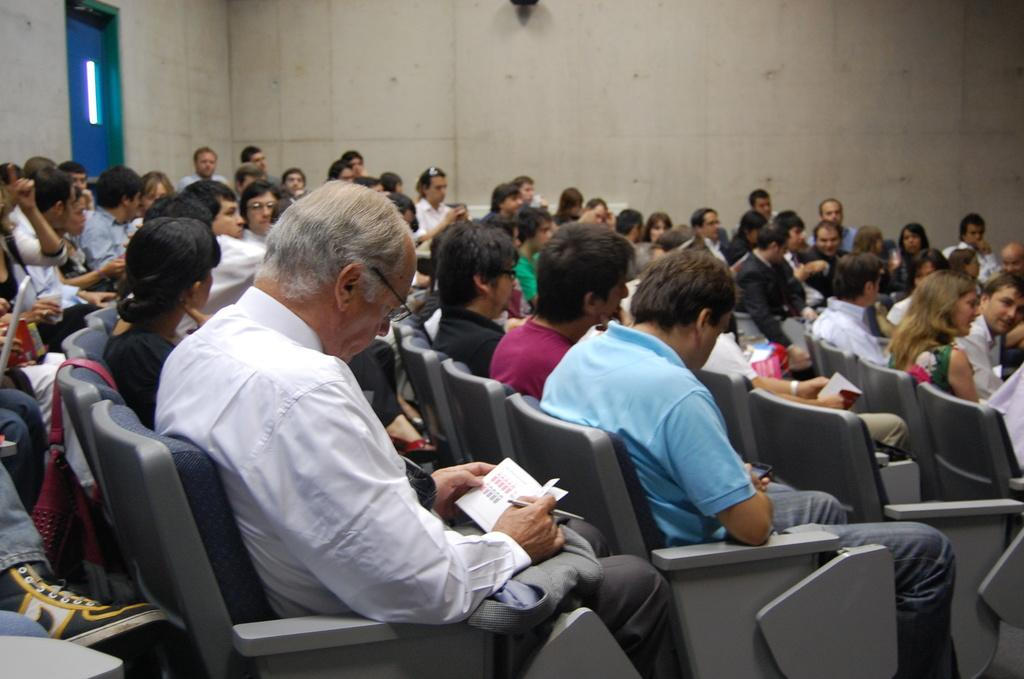How many people are in the image? There is a group of people in the image, but the exact number is not specified. What are the people doing in the image? The people are sitting on chairs in the image. What items related to learning or writing can be seen in the image? There are books and pens visible in the image. What type of personal belongings can be seen in the image? There are bags in the image. What can be seen in the background of the image? There is a wall visible in the background of the image. What type of pollution is being addressed in the image? There is no mention of pollution in the image; it features a group of people sitting with books, pens, and bags, and a wall in the background. 